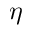<formula> <loc_0><loc_0><loc_500><loc_500>\eta</formula> 